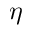<formula> <loc_0><loc_0><loc_500><loc_500>\eta</formula> 